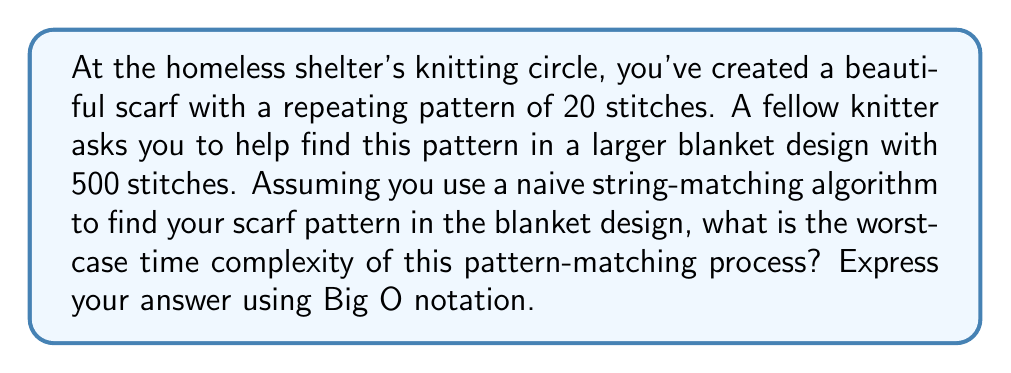Help me with this question. To solve this problem, let's break it down step-by-step:

1) In this scenario, we have:
   - Pattern length (scarf): $m = 20$ stitches
   - Text length (blanket): $n = 500$ stitches

2) The naive string-matching algorithm works by sliding the pattern over the text one by one and checking for a match at each position.

3) At each position, it compares up to $m$ characters (in the worst case, when all characters match except the last one).

4) The algorithm can start at $n - m + 1$ positions in the text.

5) Therefore, the total number of character comparisons in the worst case is:

   $$(n - m + 1) * m$$

6) Substituting our values:

   $$(500 - 20 + 1) * 20 = 481 * 20 = 9620$$

7) However, for Big O notation, we're interested in the growth rate as input sizes increase. In the general case, this is:

   $$O((n - m + 1) * m)$$

8) When $n$ is much larger than $m$ (as is often the case in pattern matching), this simplifies to:

   $$O(n * m)$$

9) In Big O notation, we drop constant factors and lower-order terms. Since $m$ is fixed in this case (the scarf pattern doesn't change), we can consider it a constant.

Therefore, the worst-case time complexity simplifies to $O(n)$.
Answer: $O(n)$ 